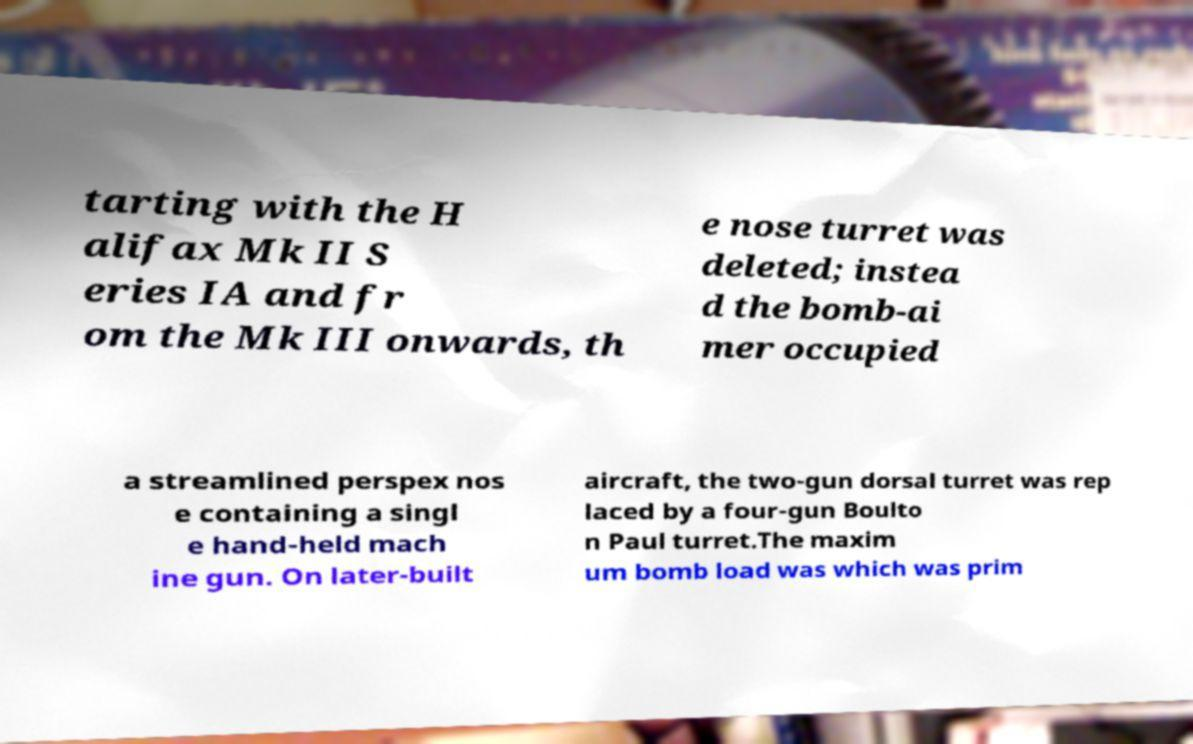Can you read and provide the text displayed in the image?This photo seems to have some interesting text. Can you extract and type it out for me? tarting with the H alifax Mk II S eries IA and fr om the Mk III onwards, th e nose turret was deleted; instea d the bomb-ai mer occupied a streamlined perspex nos e containing a singl e hand-held mach ine gun. On later-built aircraft, the two-gun dorsal turret was rep laced by a four-gun Boulto n Paul turret.The maxim um bomb load was which was prim 